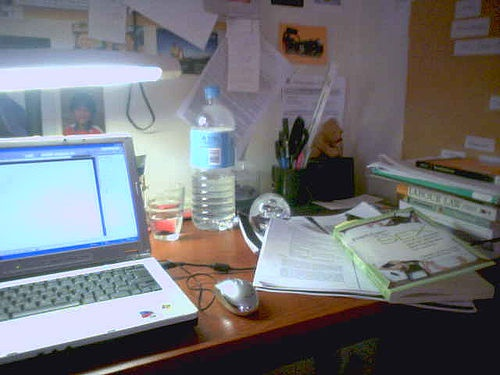Describe the objects in this image and their specific colors. I can see laptop in gray, lavender, and lightblue tones, book in gray, darkgray, and black tones, book in gray, lightblue, and darkgray tones, bottle in gray, darkgray, and lightblue tones, and cup in gray, beige, darkgray, and lightpink tones in this image. 